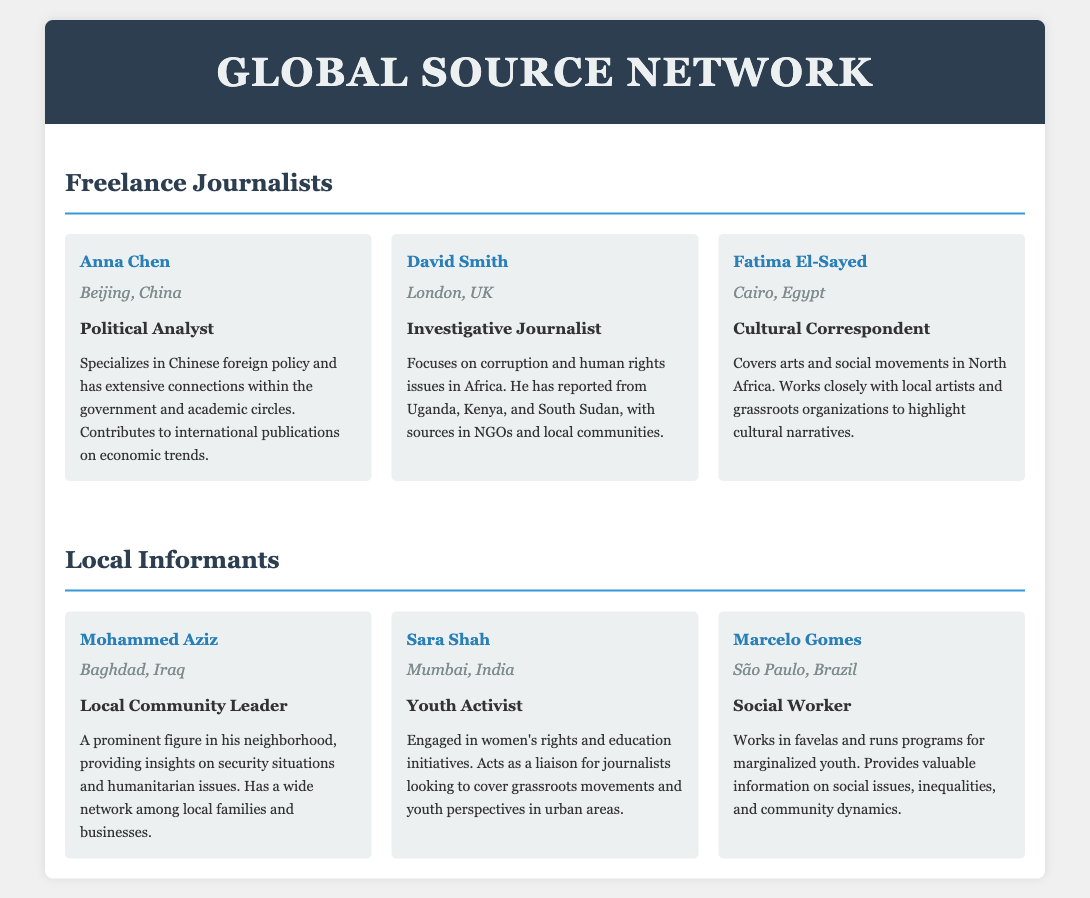What is Anna Chen's location? Anna Chen is based in Beijing, China, as indicated in her contact details.
Answer: Beijing, China Who is the cultural correspondent based in Cairo? Fatima El-Sayed is identified as the cultural correspondent located in Cairo, Egypt.
Answer: Fatima El-Sayed What is David Smith's primary focus as a journalist? David Smith's main focus is on corruption and human rights issues in Africa, as stated in his role description.
Answer: Corruption and human rights What role does Mohammed Aziz play in his community? Mohammed Aziz is described as a local community leader, providing insights on various issues.
Answer: Local Community Leader Which freelance journalist specializes in Chinese foreign policy? Anna Chen is noted for specializing in Chinese foreign policy and has connections in relevant circles.
Answer: Anna Chen What type of activist is Sara Shah? Sara Shah is identified as a youth activist, engaged in women's rights and education initiatives.
Answer: Youth Activist How many freelance journalists are mentioned in the document? The document lists three freelance journalists.
Answer: Three What is Marcelo Gomes's location and area of work? Marcelo Gomes works in São Paulo, Brazil, focusing on marginalized youth in favelas.
Answer: São Paulo, Brazil How does Fatima El-Sayed collaborate with local groups? She works closely with local artists and grassroots organizations to highlight cultural narratives.
Answer: Local artists and grassroots organizations 